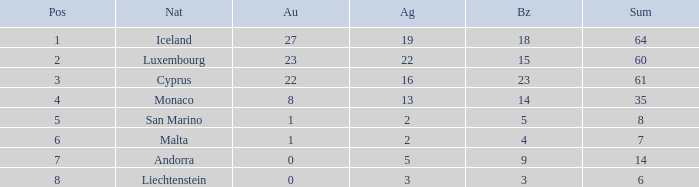How many golds for the nation with 14 total? 0.0. 